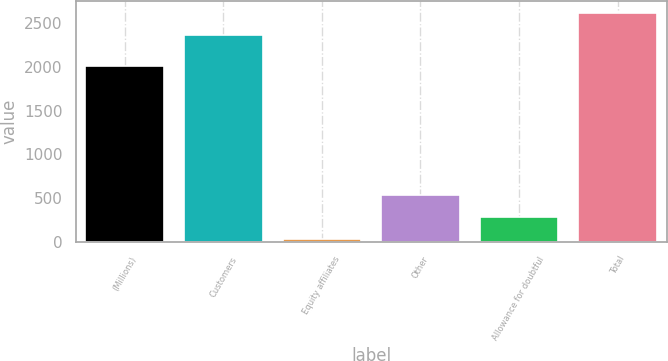Convert chart. <chart><loc_0><loc_0><loc_500><loc_500><bar_chart><fcel>(Millions)<fcel>Customers<fcel>Equity affiliates<fcel>Other<fcel>Allowance for doubtful<fcel>Total<nl><fcel>2007<fcel>2369<fcel>35<fcel>532.4<fcel>283.7<fcel>2617.7<nl></chart> 